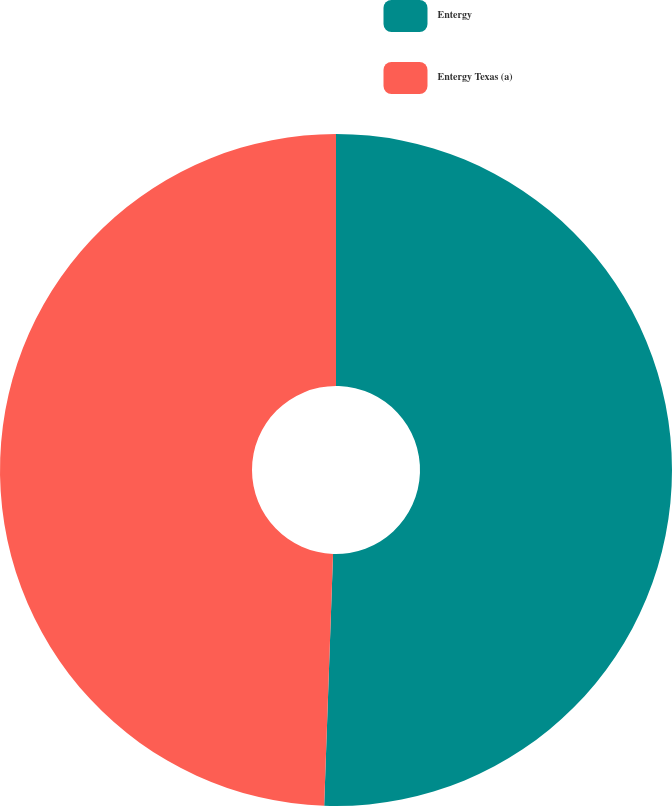<chart> <loc_0><loc_0><loc_500><loc_500><pie_chart><fcel>Entergy<fcel>Entergy Texas (a)<nl><fcel>50.56%<fcel>49.44%<nl></chart> 